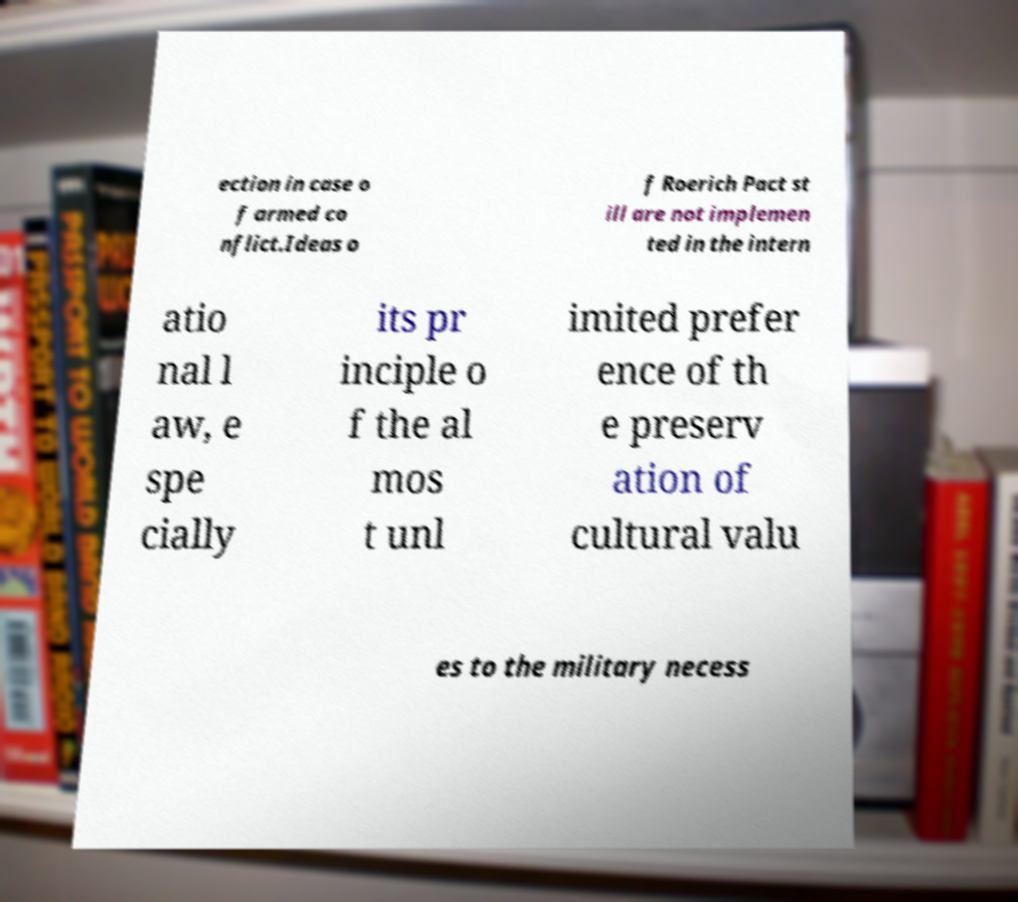Please read and relay the text visible in this image. What does it say? ection in case o f armed co nflict.Ideas o f Roerich Pact st ill are not implemen ted in the intern atio nal l aw, e spe cially its pr inciple o f the al mos t unl imited prefer ence of th e preserv ation of cultural valu es to the military necess 